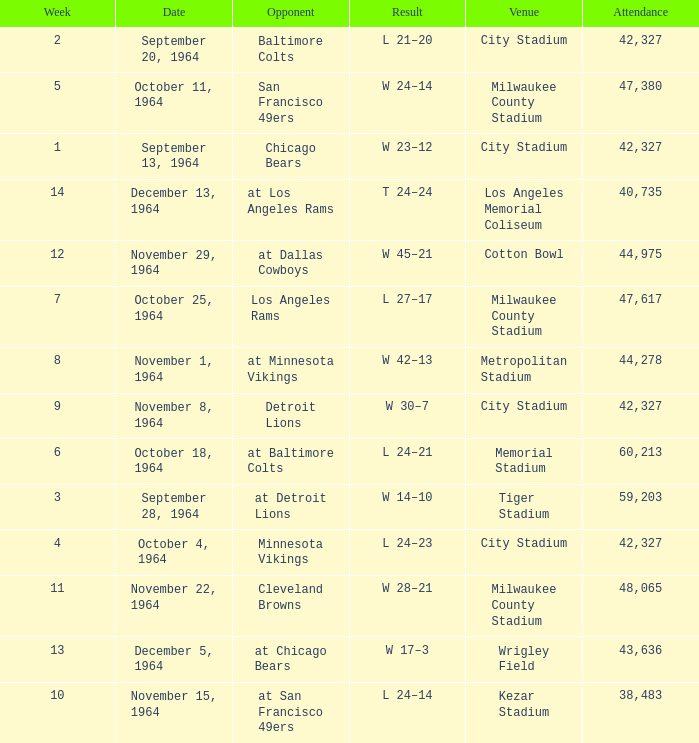What is the average week of the game on November 22, 1964 attended by 48,065? None. 